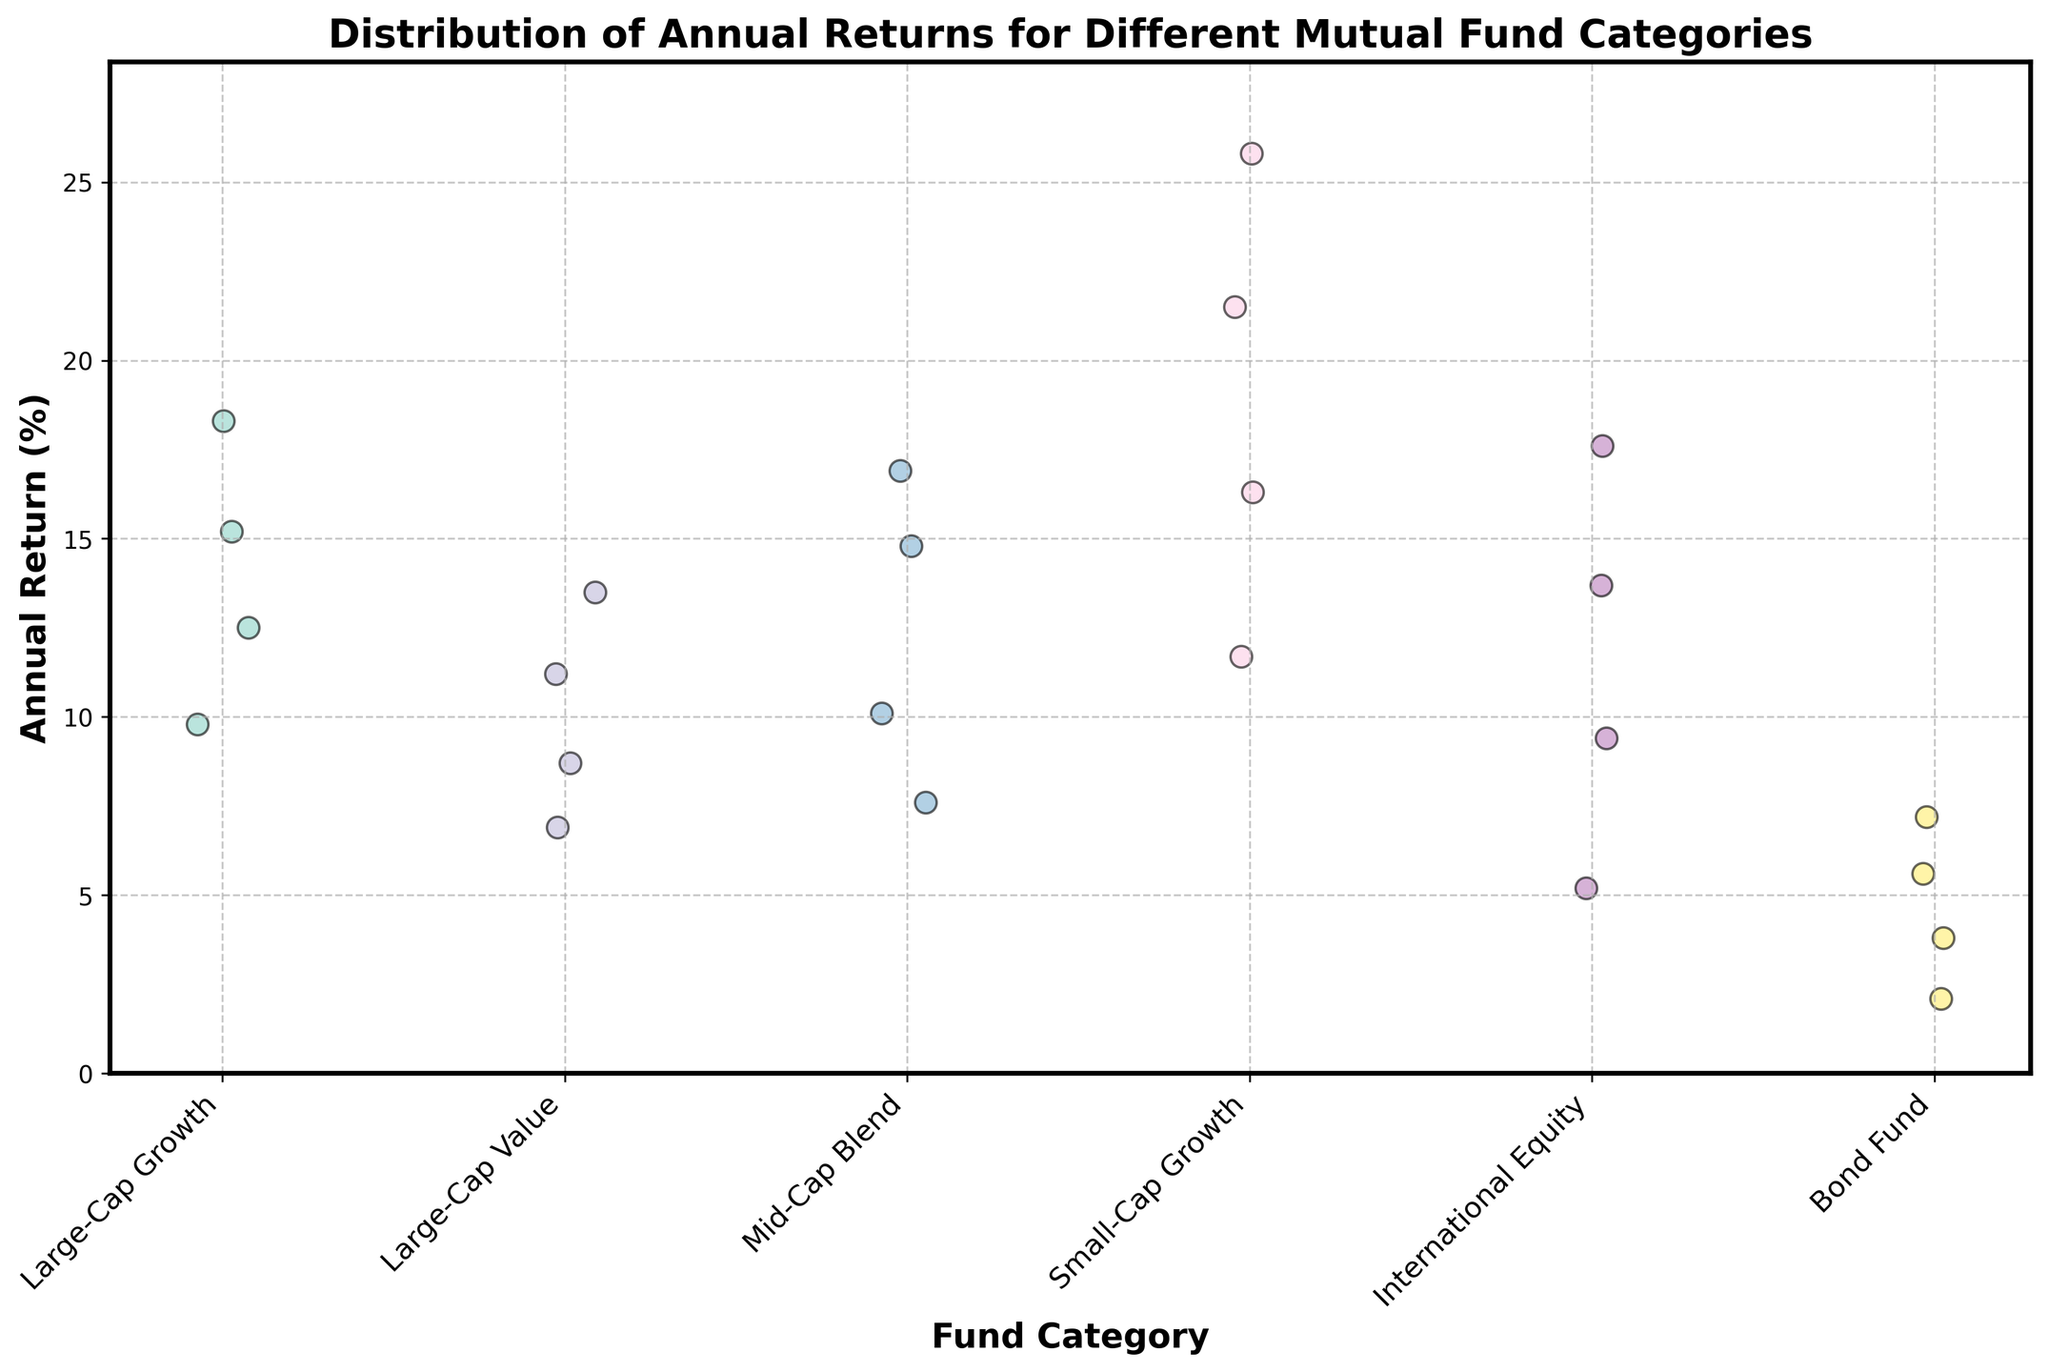What is the title of the plot? The title of the plot is displayed at the top, written in bold. It helps understand the context of the data being visualized.
Answer: Distribution of Annual Returns for Different Mutual Fund Categories How many unique fund categories are there? By counting the unique labels on the x-axis, we can determine the number of different fund categories.
Answer: 6 Which fund category has the highest annual return data point? We compare all the dot heights across categories to find the tallest one, representing the highest return.
Answer: Small-Cap Growth What is the range of annual returns for the International Equity category? Look at the lowest and highest dots in the International Equity category to determine the range.
Answer: 5.2% to 17.6% How do the median returns of Large-Cap Growth and Large-Cap Value compare? For each category, the median can be estimated by visually identifying the middle point of the data distribution. Comparing these medians gives insight into their central tendencies.
Answer: Large-Cap Growth has a higher median return than Large-Cap Value Which category shows the lowest variability in annual returns? The category with the least spread (smallest vertical range of dots) has the lowest variability.
Answer: Bond Fund Which fund category has the broadest range of annual returns? By identifying the category with the most vertically spread-out dots, we can determine which category has the highest range.
Answer: Small-Cap Growth How many data points are there for the Mid-Cap Blend category? By counting the dots over the Mid-Cap Blend label on the x-axis, we get the total number of data points for that category.
Answer: 4 Are the annual returns for Bond Fund generally higher or lower than those for Large-Cap Growth? By comparing the vertical positions of dots in both categories, we can determine the overall trend in their returns.
Answer: Lower Which categories have annual returns that surpass 20%? We identify all the dots above the 20% mark and note their corresponding categories.
Answer: Small-Cap Growth 